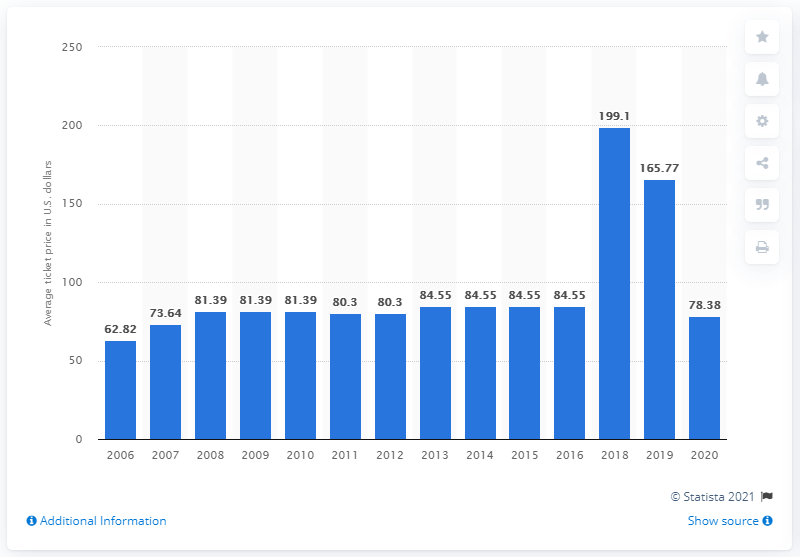Draw attention to some important aspects in this diagram. The average ticket price in 2020 was 78.38 